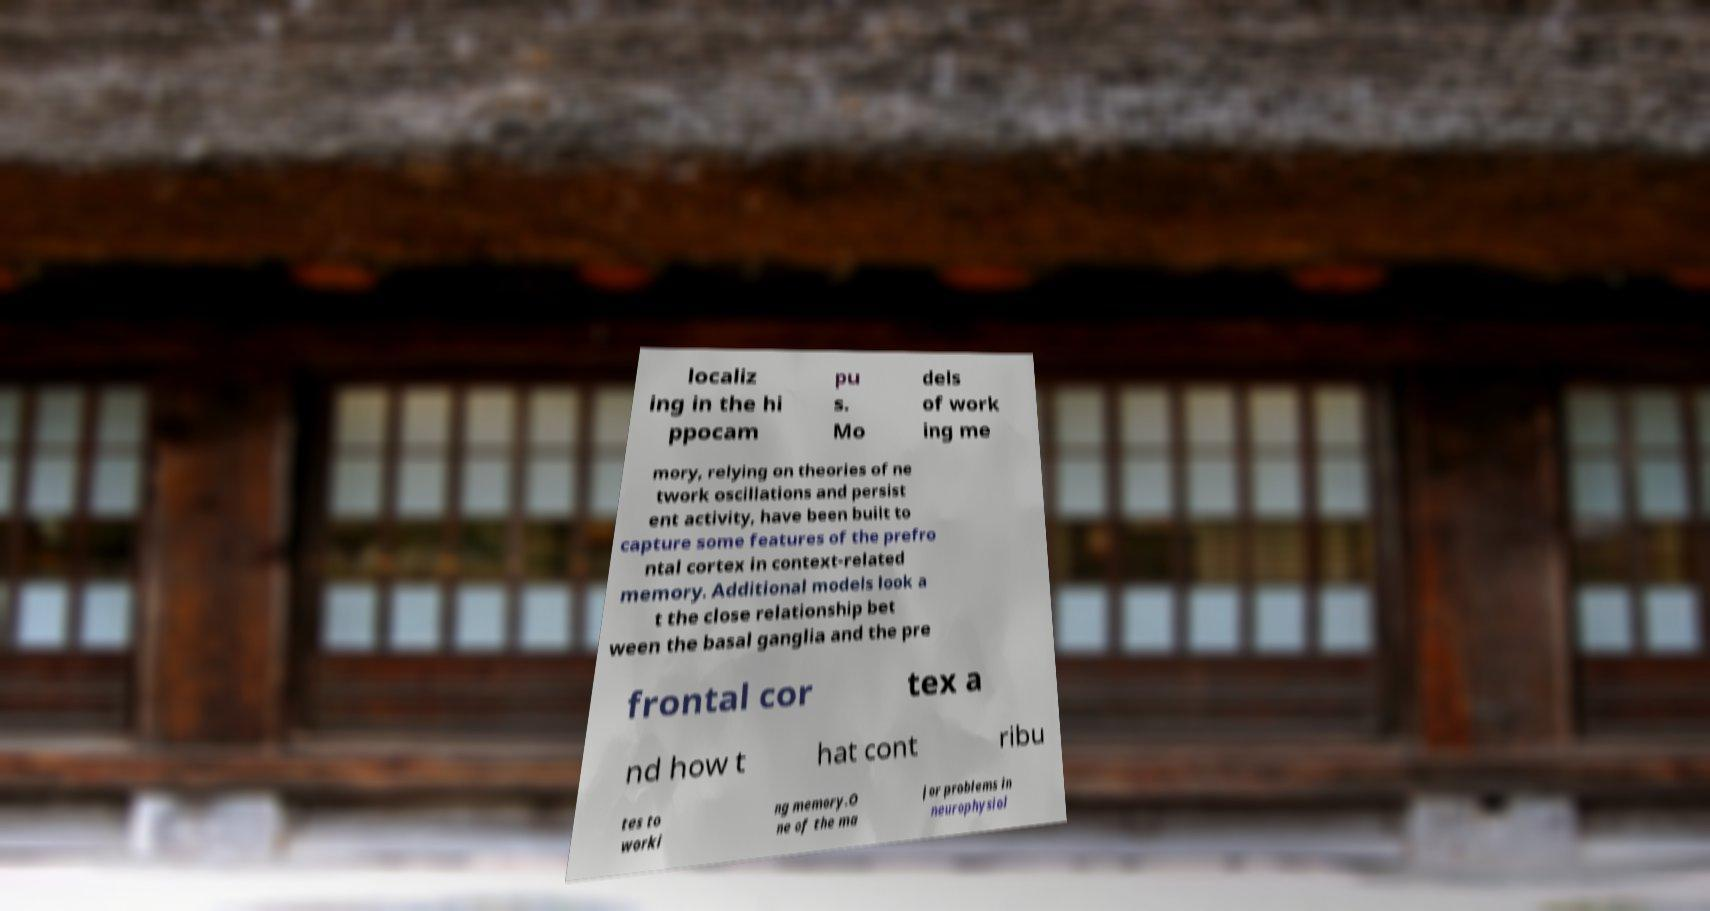What messages or text are displayed in this image? I need them in a readable, typed format. localiz ing in the hi ppocam pu s. Mo dels of work ing me mory, relying on theories of ne twork oscillations and persist ent activity, have been built to capture some features of the prefro ntal cortex in context-related memory. Additional models look a t the close relationship bet ween the basal ganglia and the pre frontal cor tex a nd how t hat cont ribu tes to worki ng memory.O ne of the ma jor problems in neurophysiol 